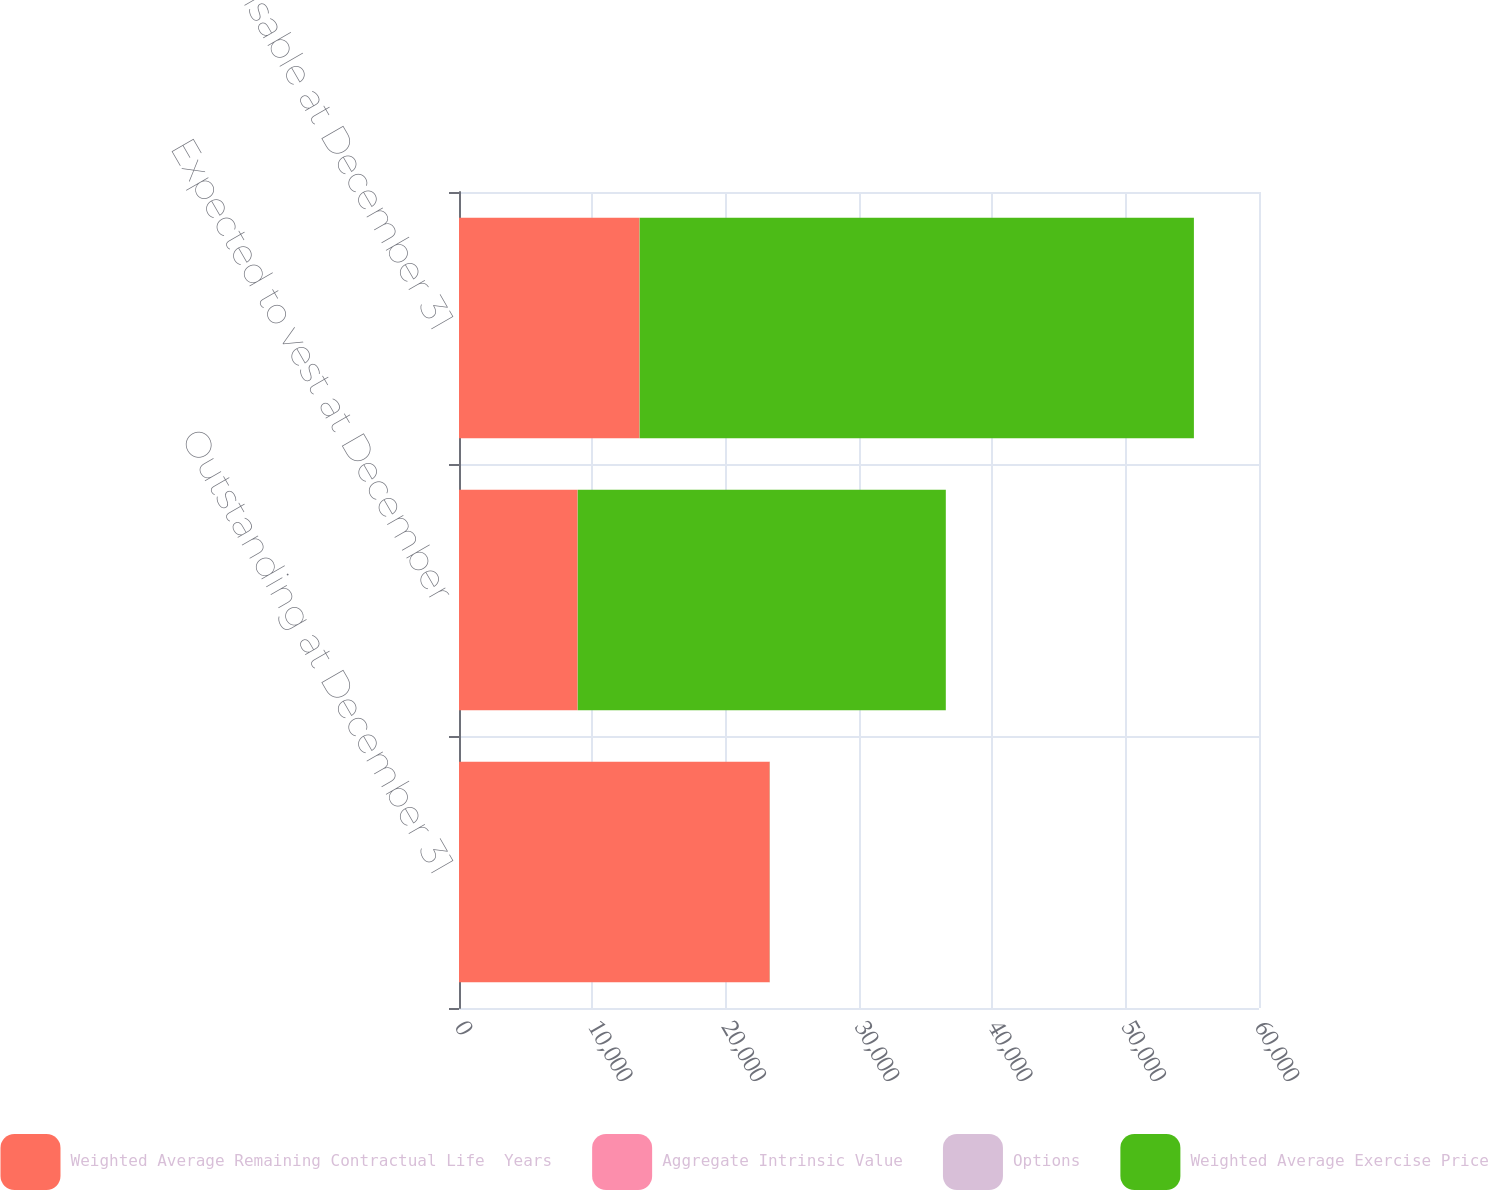<chart> <loc_0><loc_0><loc_500><loc_500><stacked_bar_chart><ecel><fcel>Outstanding at December 31<fcel>Expected to vest at December<fcel>Exercisable at December 31<nl><fcel>Weighted Average Remaining Contractual Life  Years<fcel>23300<fcel>8893<fcel>13536<nl><fcel>Aggregate Intrinsic Value<fcel>7.61<fcel>6.55<fcel>8.37<nl><fcel>Options<fcel>4.2<fcel>5.3<fcel>3.4<nl><fcel>Weighted Average Exercise Price<fcel>8.37<fcel>27606<fcel>41570<nl></chart> 